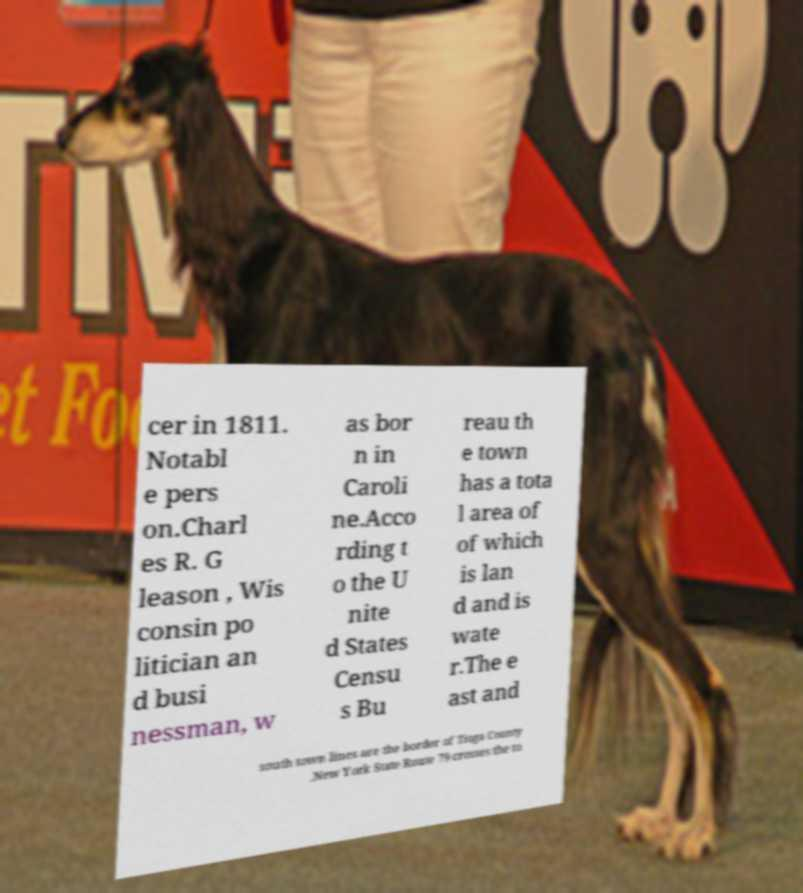Please identify and transcribe the text found in this image. cer in 1811. Notabl e pers on.Charl es R. G leason , Wis consin po litician an d busi nessman, w as bor n in Caroli ne.Acco rding t o the U nite d States Censu s Bu reau th e town has a tota l area of of which is lan d and is wate r.The e ast and south town lines are the border of Tioga County .New York State Route 79 crosses the to 